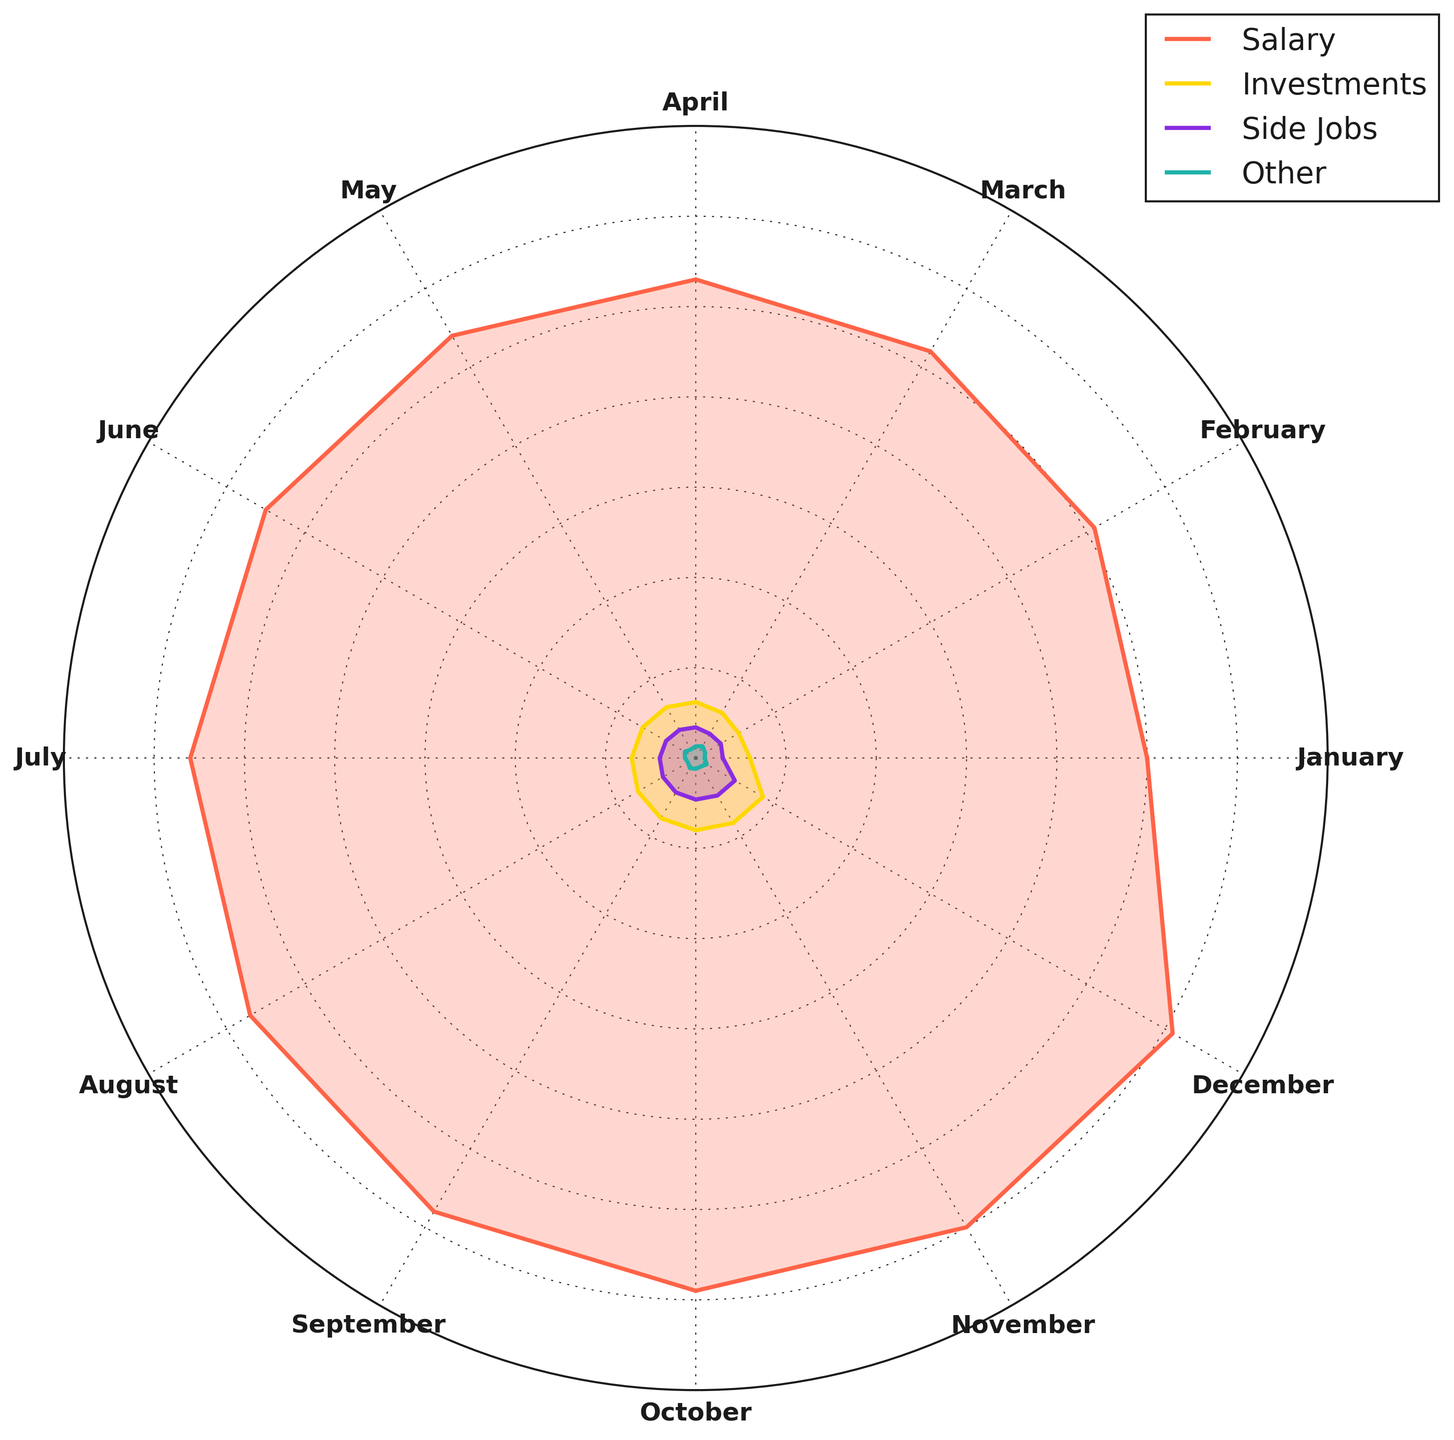what is the dominant income source over the year? By reviewing the rose chart, observe which income source has the largest area covered compared to others throughout the year. The chart shows that the salary arc is consistently the longest in each month.
Answer: Salary In which month does "Investments" contribute the most to income? Locate and track the "Investments" segment month by month. In December, "Investments" hits its peak with the highest outward stretch.
Answer: December How does the amount from "Side Jobs" in June compare to that in December? Examine the arcs for "Side Jobs" in June and December. Visually, the arcs indicate that the value is higher in December than in June.
Answer: December is higher What is the total income in July combining all sources? Sum up the values for each income source in July. The salary is 5600, investments are 710, side jobs are 400, and other is 120. The calculation is 5600 + 710 + 400 + 120 = 6830.
Answer: 6830 Which month has the least income from "Other"? Trace the "Other" segments and identify the month with the innermost arc. January and August both have the least contribution with 100.
Answer: January and August What is the average monthly income from "Salary"? Sum up the salary values across all months and divide by 12. The sum is 5000+5100+5200+5300+5400+5500+5600+5700+5800+5900+6000+6100=66600. The average is 66600/12=5550.
Answer: 5550 Which income source saw the highest incremental increase from January to December? Examine the increments of each income source from January to December. "Salary" increased from 5000 to 6100, "Investments" from 600 to 860, "Side Jobs" from 300 to 500, and "Other" from 100 to 140. Calculate each increment: Salary (1100), Investments (260), Side Jobs (200), Other (40).
Answer: Salary Is there any month where income from "Side Jobs" is greater than income from "Investments"? Compare the lengths of the arcs for "Side Jobs" and "Investments" month by month. None of the months have a "Side Jobs" arc greater than the "Investments" arc.
Answer: No Which income source is depicted with a blue color in the rose chart? Identify the color used for each income source in the figure. "Investments" is shown in blue.
Answer: Investments Compare the total contributions from "Other" and "Side Jobs" across the year. Which is higher? Sum up the values for "Other" and "Side Jobs" for the entire year. Total for "Other" is 100+120+150+130+110+140+120+100+130+120+110+140=1370 and for "Side Jobs" is 300+320+310+340+360+380+400+420+440+460+480+500=4630. Compare the two totals: 1370 < 4630.
Answer: Side Jobs 